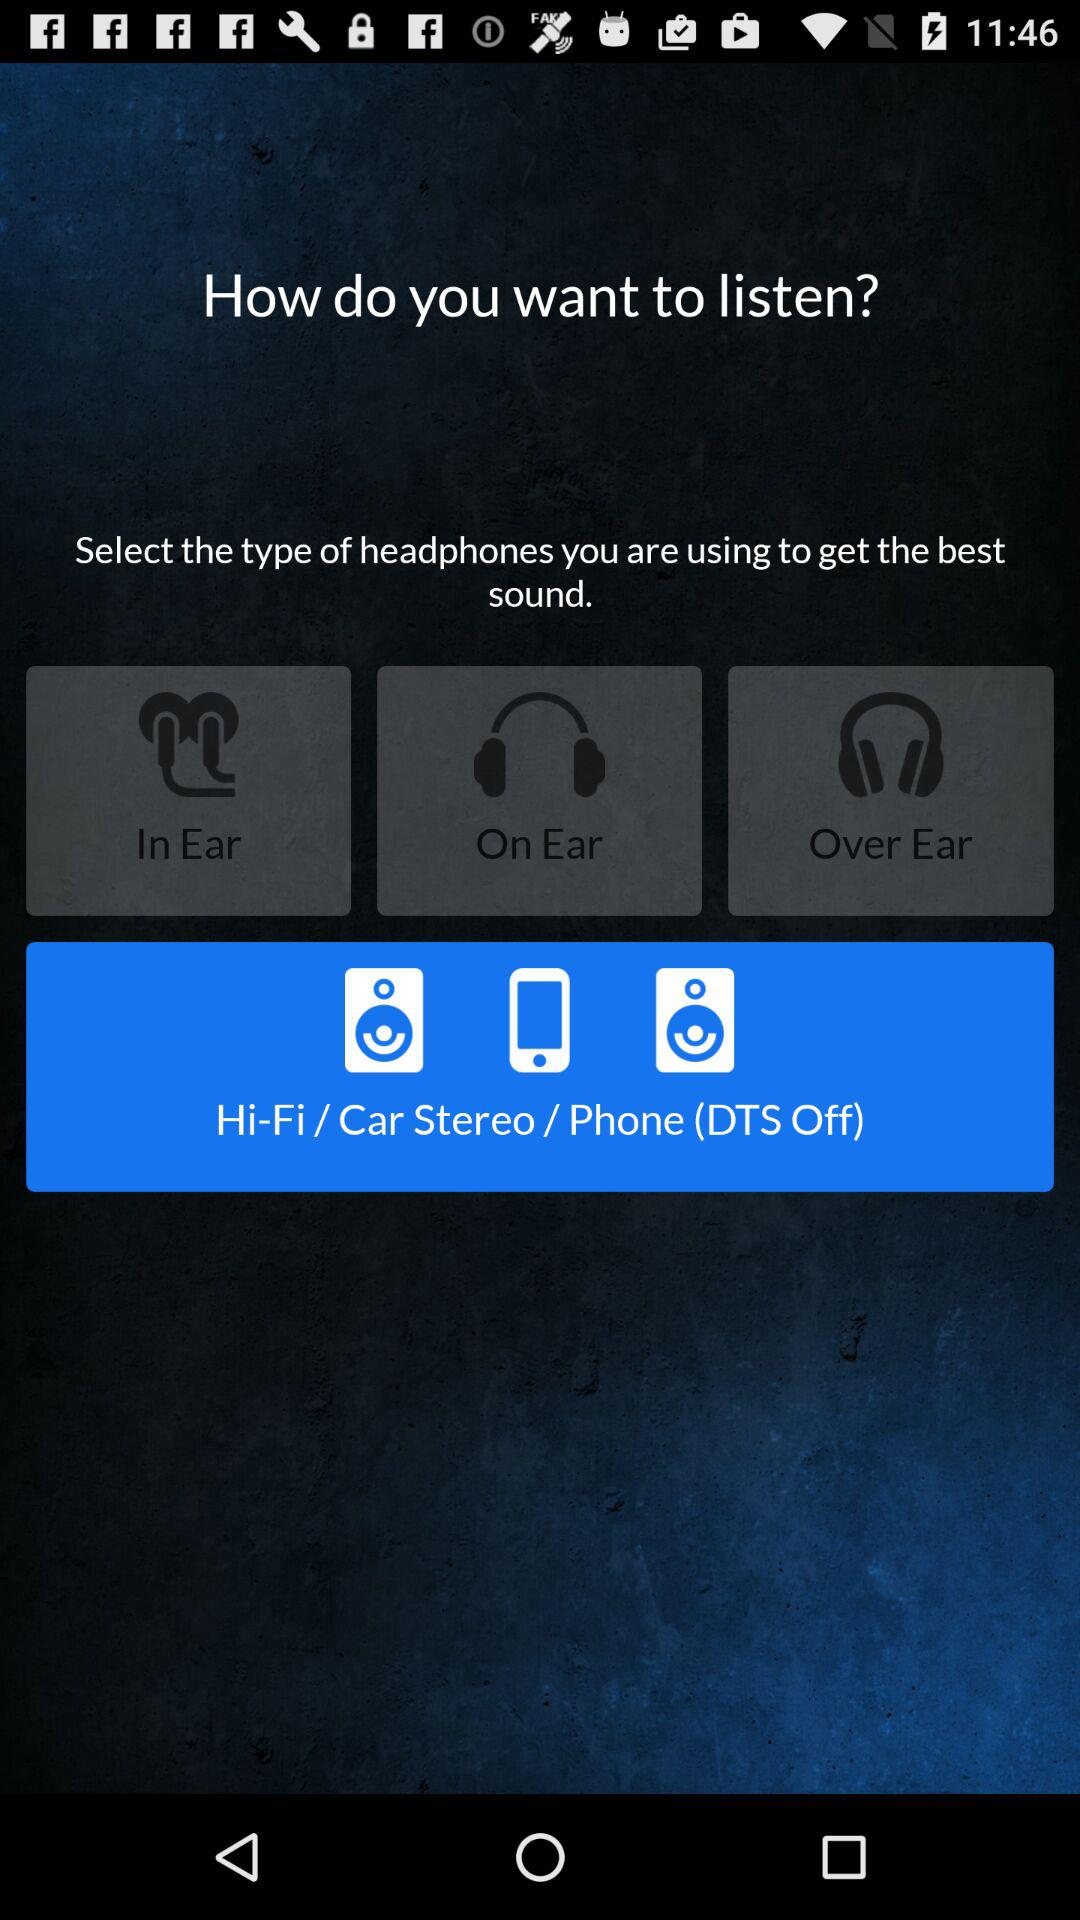How many headphones types are there?
Answer the question using a single word or phrase. 3 